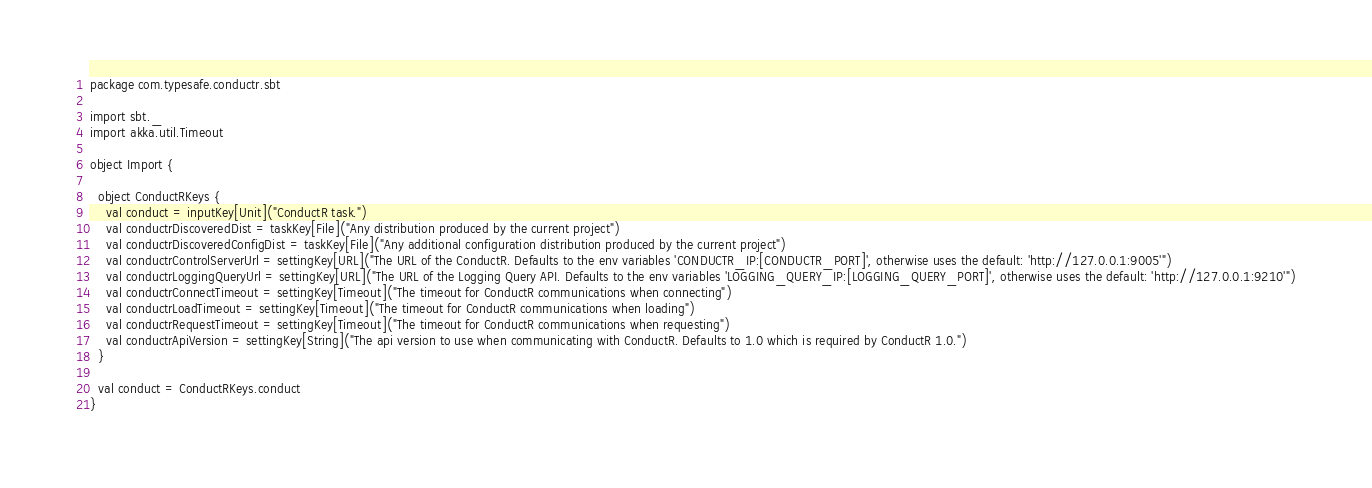Convert code to text. <code><loc_0><loc_0><loc_500><loc_500><_Scala_>
package com.typesafe.conductr.sbt

import sbt._
import akka.util.Timeout

object Import {

  object ConductRKeys {
    val conduct = inputKey[Unit]("ConductR task.")
    val conductrDiscoveredDist = taskKey[File]("Any distribution produced by the current project")
    val conductrDiscoveredConfigDist = taskKey[File]("Any additional configuration distribution produced by the current project")
    val conductrControlServerUrl = settingKey[URL]("The URL of the ConductR. Defaults to the env variables 'CONDUCTR_IP:[CONDUCTR_PORT]', otherwise uses the default: 'http://127.0.0.1:9005'")
    val conductrLoggingQueryUrl = settingKey[URL]("The URL of the Logging Query API. Defaults to the env variables 'LOGGING_QUERY_IP:[LOGGING_QUERY_PORT]', otherwise uses the default: 'http://127.0.0.1:9210'")
    val conductrConnectTimeout = settingKey[Timeout]("The timeout for ConductR communications when connecting")
    val conductrLoadTimeout = settingKey[Timeout]("The timeout for ConductR communications when loading")
    val conductrRequestTimeout = settingKey[Timeout]("The timeout for ConductR communications when requesting")
    val conductrApiVersion = settingKey[String]("The api version to use when communicating with ConductR. Defaults to 1.0 which is required by ConductR 1.0.")
  }

  val conduct = ConductRKeys.conduct
}</code> 